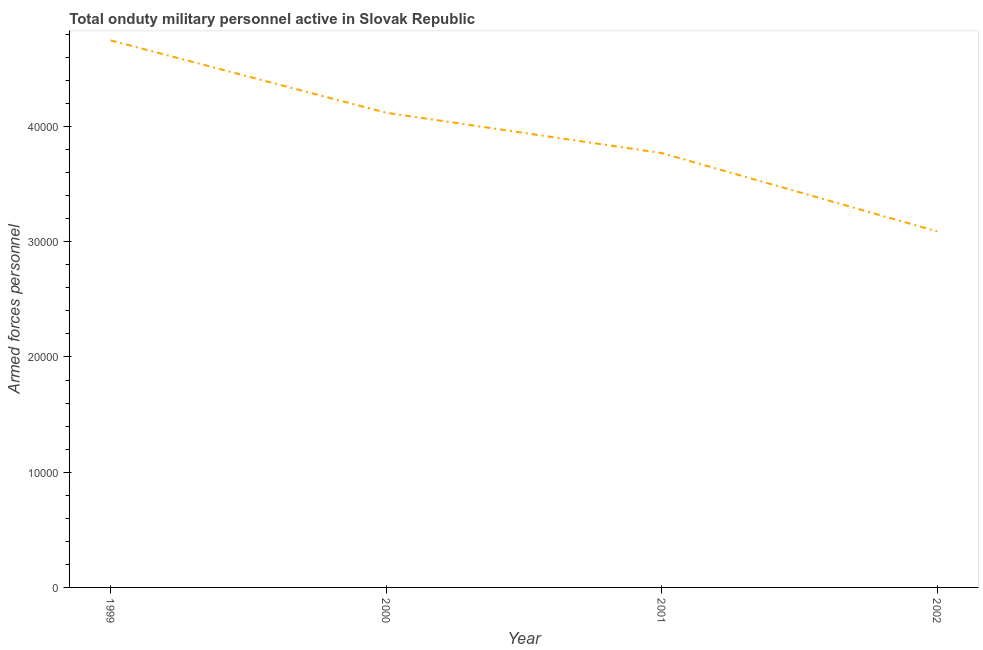What is the number of armed forces personnel in 1999?
Keep it short and to the point. 4.75e+04. Across all years, what is the maximum number of armed forces personnel?
Make the answer very short. 4.75e+04. Across all years, what is the minimum number of armed forces personnel?
Give a very brief answer. 3.09e+04. What is the sum of the number of armed forces personnel?
Ensure brevity in your answer.  1.57e+05. What is the difference between the number of armed forces personnel in 1999 and 2002?
Provide a succinct answer. 1.66e+04. What is the average number of armed forces personnel per year?
Give a very brief answer. 3.93e+04. What is the median number of armed forces personnel?
Your answer should be compact. 3.94e+04. In how many years, is the number of armed forces personnel greater than 36000 ?
Provide a succinct answer. 3. Do a majority of the years between 2001 and 1999 (inclusive) have number of armed forces personnel greater than 18000 ?
Provide a succinct answer. No. What is the ratio of the number of armed forces personnel in 2000 to that in 2001?
Offer a terse response. 1.09. Is the number of armed forces personnel in 2001 less than that in 2002?
Ensure brevity in your answer.  No. What is the difference between the highest and the second highest number of armed forces personnel?
Your answer should be very brief. 6280. Is the sum of the number of armed forces personnel in 2000 and 2001 greater than the maximum number of armed forces personnel across all years?
Your answer should be very brief. Yes. What is the difference between the highest and the lowest number of armed forces personnel?
Your response must be concise. 1.66e+04. How many lines are there?
Provide a short and direct response. 1. How many years are there in the graph?
Ensure brevity in your answer.  4. What is the difference between two consecutive major ticks on the Y-axis?
Give a very brief answer. 10000. Does the graph contain any zero values?
Your answer should be compact. No. What is the title of the graph?
Provide a succinct answer. Total onduty military personnel active in Slovak Republic. What is the label or title of the Y-axis?
Ensure brevity in your answer.  Armed forces personnel. What is the Armed forces personnel in 1999?
Ensure brevity in your answer.  4.75e+04. What is the Armed forces personnel in 2000?
Your response must be concise. 4.12e+04. What is the Armed forces personnel in 2001?
Provide a short and direct response. 3.77e+04. What is the Armed forces personnel in 2002?
Make the answer very short. 3.09e+04. What is the difference between the Armed forces personnel in 1999 and 2000?
Your answer should be very brief. 6280. What is the difference between the Armed forces personnel in 1999 and 2001?
Your answer should be very brief. 9780. What is the difference between the Armed forces personnel in 1999 and 2002?
Provide a succinct answer. 1.66e+04. What is the difference between the Armed forces personnel in 2000 and 2001?
Give a very brief answer. 3500. What is the difference between the Armed forces personnel in 2000 and 2002?
Offer a very short reply. 1.03e+04. What is the difference between the Armed forces personnel in 2001 and 2002?
Make the answer very short. 6800. What is the ratio of the Armed forces personnel in 1999 to that in 2000?
Provide a short and direct response. 1.15. What is the ratio of the Armed forces personnel in 1999 to that in 2001?
Offer a terse response. 1.26. What is the ratio of the Armed forces personnel in 1999 to that in 2002?
Offer a terse response. 1.54. What is the ratio of the Armed forces personnel in 2000 to that in 2001?
Keep it short and to the point. 1.09. What is the ratio of the Armed forces personnel in 2000 to that in 2002?
Your response must be concise. 1.33. What is the ratio of the Armed forces personnel in 2001 to that in 2002?
Provide a succinct answer. 1.22. 